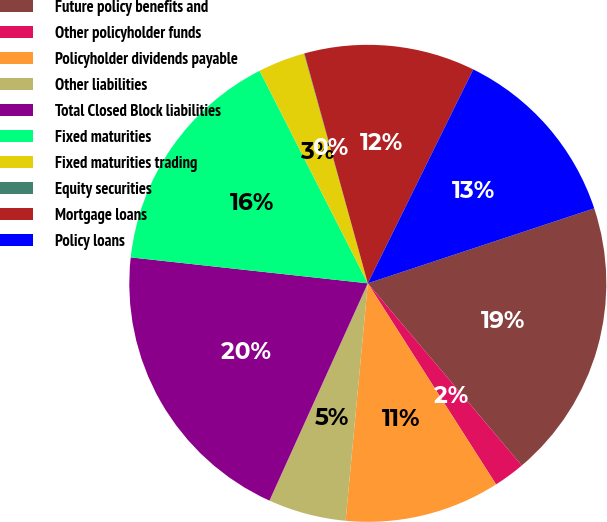Convert chart. <chart><loc_0><loc_0><loc_500><loc_500><pie_chart><fcel>Future policy benefits and<fcel>Other policyholder funds<fcel>Policyholder dividends payable<fcel>Other liabilities<fcel>Total Closed Block liabilities<fcel>Fixed maturities<fcel>Fixed maturities trading<fcel>Equity securities<fcel>Mortgage loans<fcel>Policy loans<nl><fcel>18.92%<fcel>2.13%<fcel>10.52%<fcel>5.28%<fcel>19.97%<fcel>15.77%<fcel>3.18%<fcel>0.03%<fcel>11.57%<fcel>12.62%<nl></chart> 